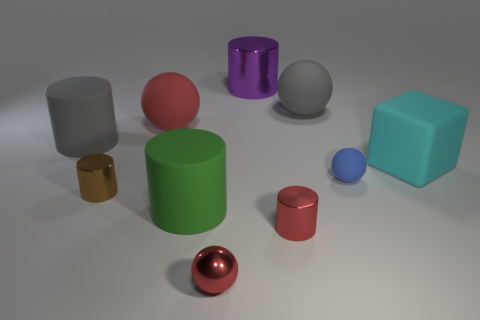Subtract all small metal balls. How many balls are left? 3 Subtract all purple cylinders. How many cylinders are left? 4 Subtract all balls. How many objects are left? 6 Subtract all yellow cubes. Subtract all gray spheres. How many cubes are left? 1 Subtract all purple blocks. How many red spheres are left? 2 Subtract all red balls. Subtract all big metallic things. How many objects are left? 7 Add 3 cyan rubber objects. How many cyan rubber objects are left? 4 Add 8 blue balls. How many blue balls exist? 9 Subtract 0 cyan spheres. How many objects are left? 10 Subtract 3 spheres. How many spheres are left? 1 